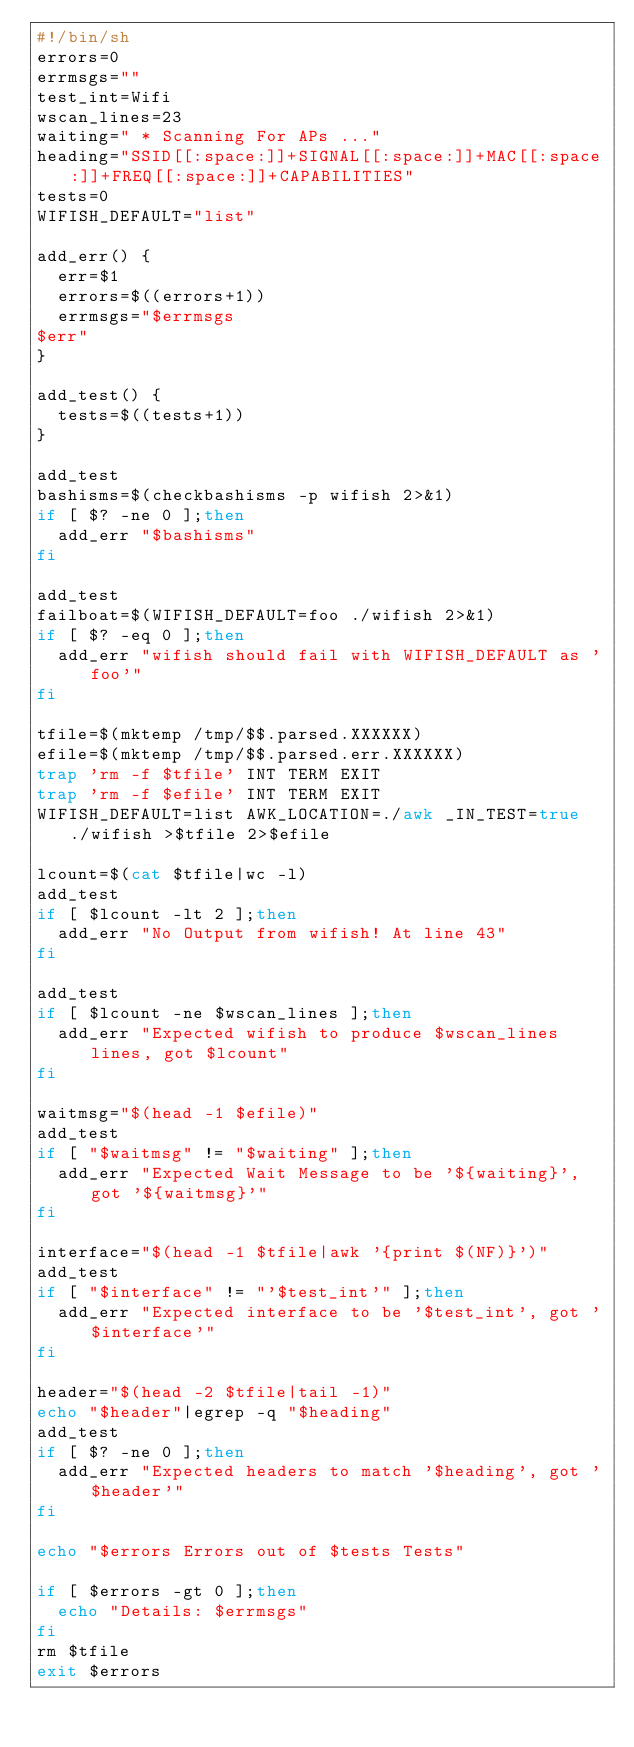Convert code to text. <code><loc_0><loc_0><loc_500><loc_500><_Bash_>#!/bin/sh
errors=0
errmsgs=""
test_int=Wifi
wscan_lines=23
waiting=" * Scanning For APs ..."
heading="SSID[[:space:]]+SIGNAL[[:space:]]+MAC[[:space:]]+FREQ[[:space:]]+CAPABILITIES"
tests=0
WIFISH_DEFAULT="list"

add_err() {
	err=$1
	errors=$((errors+1))
	errmsgs="$errmsgs
$err"
}

add_test() {
	tests=$((tests+1))
}

add_test
bashisms=$(checkbashisms -p wifish 2>&1)
if [ $? -ne 0 ];then
	add_err "$bashisms"
fi

add_test
failboat=$(WIFISH_DEFAULT=foo ./wifish 2>&1)
if [ $? -eq 0 ];then
	add_err "wifish should fail with WIFISH_DEFAULT as 'foo'"
fi

tfile=$(mktemp /tmp/$$.parsed.XXXXXX)
efile=$(mktemp /tmp/$$.parsed.err.XXXXXX)
trap 'rm -f $tfile' INT TERM EXIT
trap 'rm -f $efile' INT TERM EXIT
WIFISH_DEFAULT=list AWK_LOCATION=./awk _IN_TEST=true ./wifish >$tfile 2>$efile

lcount=$(cat $tfile|wc -l)
add_test
if [ $lcount -lt 2 ];then
	add_err "No Output from wifish! At line 43"
fi

add_test
if [ $lcount -ne $wscan_lines ];then
	add_err "Expected wifish to produce $wscan_lines lines, got $lcount"
fi

waitmsg="$(head -1 $efile)"
add_test
if [ "$waitmsg" != "$waiting" ];then
	add_err "Expected Wait Message to be '${waiting}', got '${waitmsg}'"
fi

interface="$(head -1 $tfile|awk '{print $(NF)}')"
add_test
if [ "$interface" != "'$test_int'" ];then
	add_err "Expected interface to be '$test_int', got '$interface'"
fi

header="$(head -2 $tfile|tail -1)"
echo "$header"|egrep -q "$heading"
add_test
if [ $? -ne 0 ];then
	add_err "Expected headers to match '$heading', got '$header'"
fi

echo "$errors Errors out of $tests Tests"

if [ $errors -gt 0 ];then
	echo "Details: $errmsgs"
fi
rm $tfile
exit $errors

</code> 